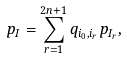<formula> <loc_0><loc_0><loc_500><loc_500>p _ { I } = \sum _ { r = 1 } ^ { 2 n + 1 } q _ { i _ { 0 } , i _ { r } } p _ { I _ { r } } ,</formula> 